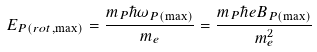Convert formula to latex. <formula><loc_0><loc_0><loc_500><loc_500>E _ { P ( r o t , \max ) } = \frac { m _ { P } \hbar { \omega } _ { P ( \max ) } } { m _ { e } } = \frac { m _ { P } \hbar { e } B _ { P ( \max ) } } { m _ { e } ^ { 2 } }</formula> 